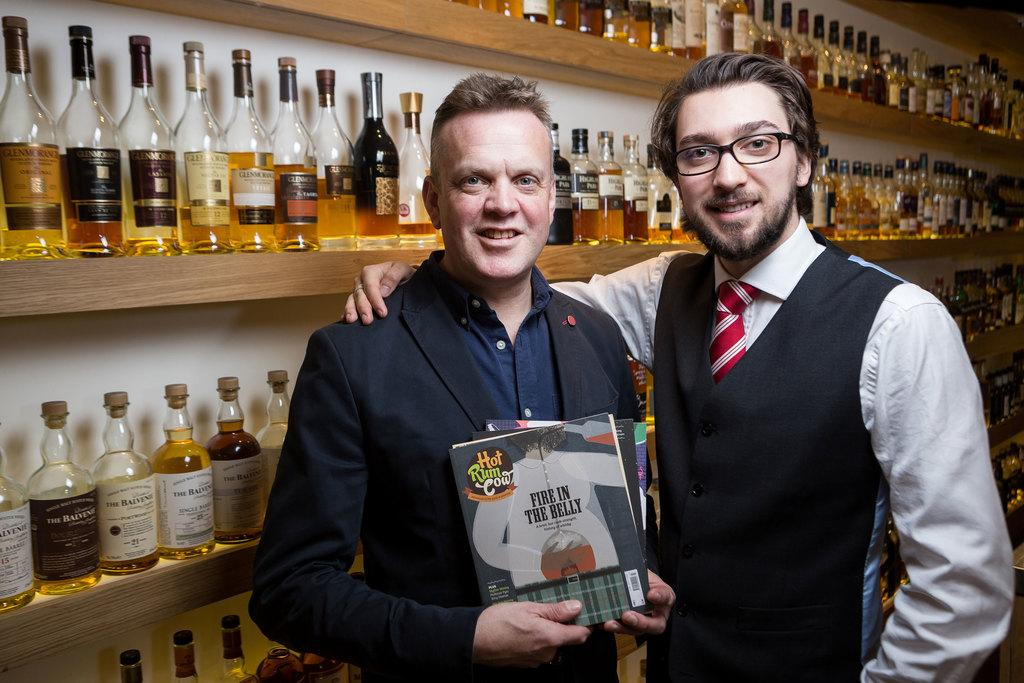How many people are in the image? There are two men in the image. What is the facial expression of the men? Both men are smiling. What is one of the men holding in his hands? One man is holding books with his hands. What can be seen in the background behind the men? There are bottles in racks at the back of the men. What type of planes are visible in the image? There are no planes visible in the image. What statement is being made by the men in the image? The image does not provide any information about a statement being made by the men. 